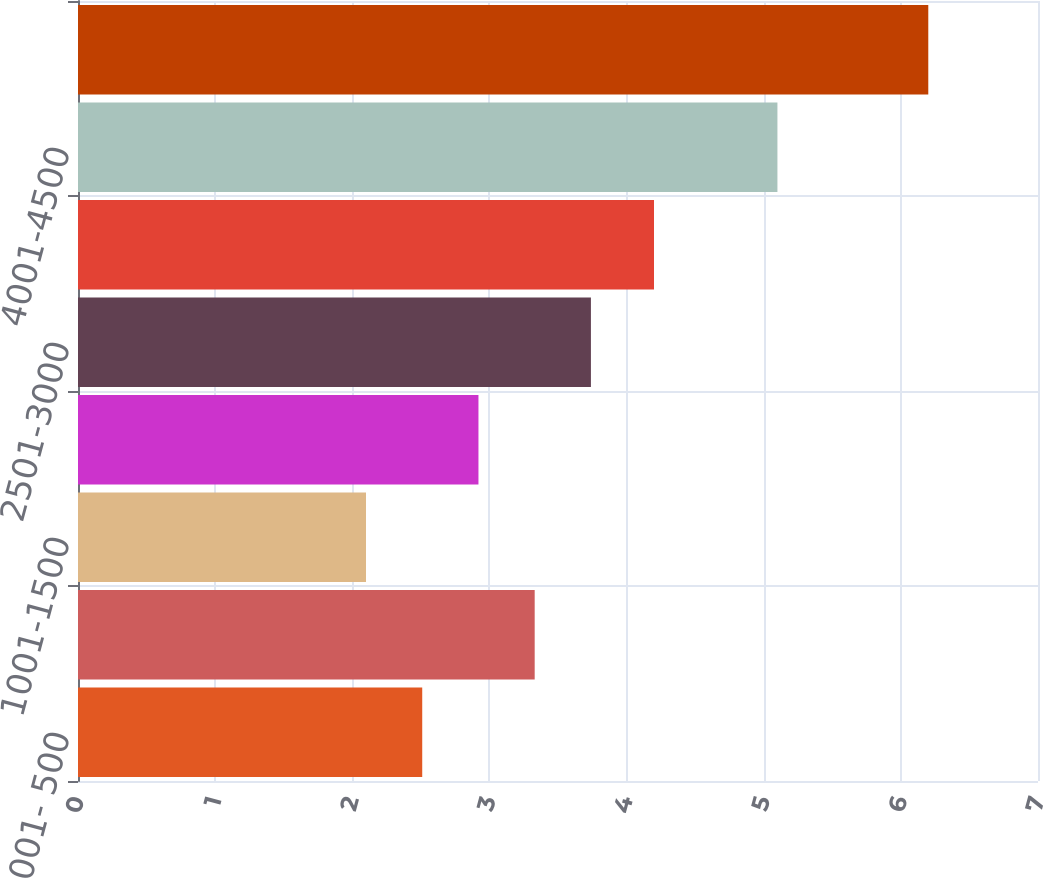Convert chart to OTSL. <chart><loc_0><loc_0><loc_500><loc_500><bar_chart><fcel>001- 500<fcel>501-1000<fcel>1001-1500<fcel>1501-2000<fcel>2501-3000<fcel>3001-3500<fcel>4001-4500<fcel>5001-5500<nl><fcel>2.51<fcel>3.33<fcel>2.1<fcel>2.92<fcel>3.74<fcel>4.2<fcel>5.1<fcel>6.2<nl></chart> 